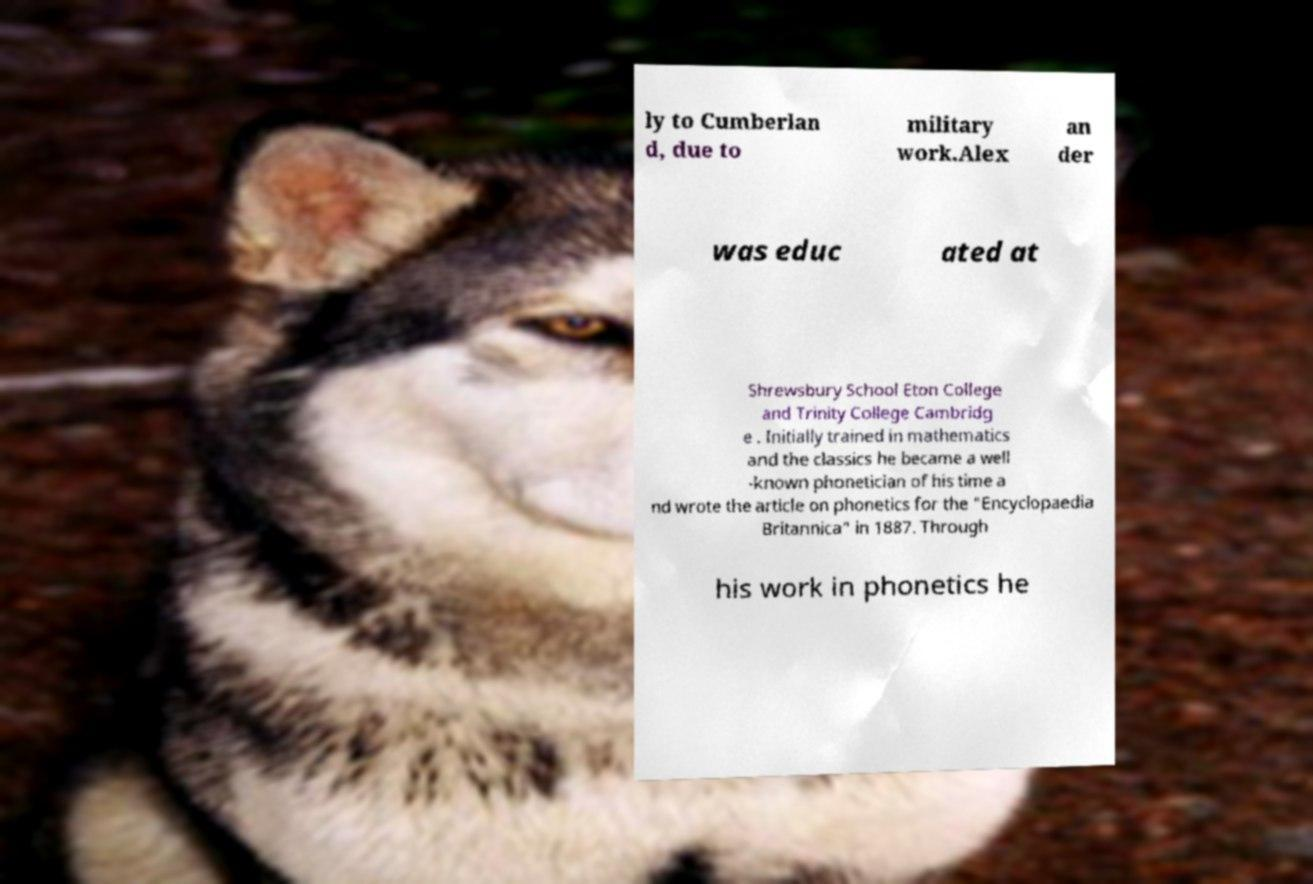Could you extract and type out the text from this image? ly to Cumberlan d, due to military work.Alex an der was educ ated at Shrewsbury School Eton College and Trinity College Cambridg e . Initially trained in mathematics and the classics he became a well -known phonetician of his time a nd wrote the article on phonetics for the "Encyclopaedia Britannica" in 1887. Through his work in phonetics he 